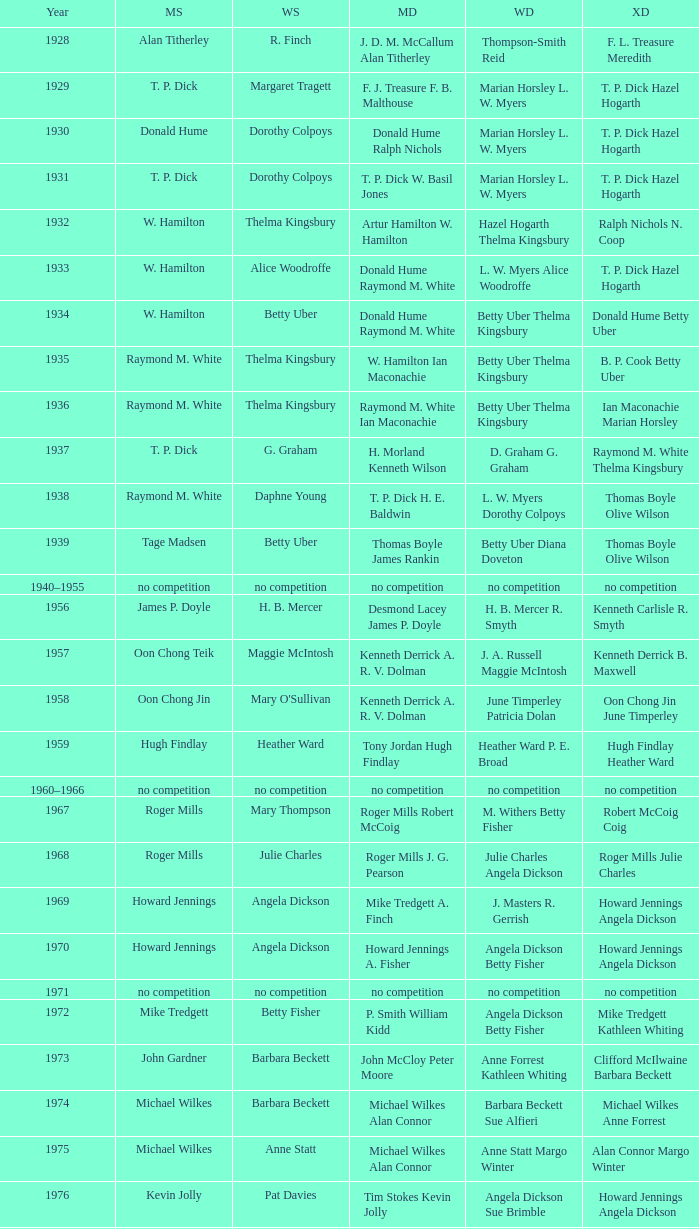Who were the winners of the women's doubles when jesper knudsen nettie nielsen secured the mixed doubles title? Karen Beckman Sara Halsall. 